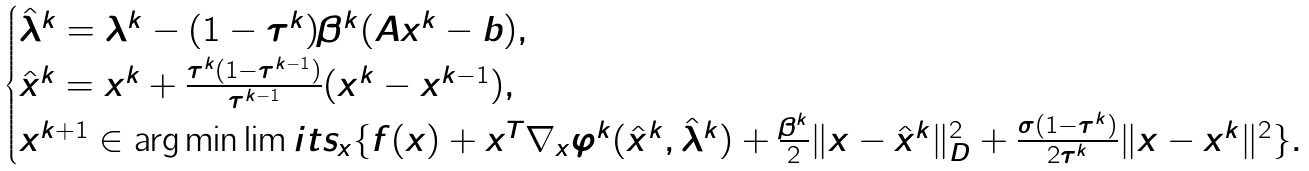<formula> <loc_0><loc_0><loc_500><loc_500>\begin{cases} \hat { \lambda } ^ { k } = \lambda ^ { k } - ( 1 - \tau ^ { k } ) \beta ^ { k } ( A { x } ^ { k } - b ) , \\ \hat { x } ^ { k } = x ^ { k } + \frac { \tau ^ { k } ( 1 - \tau ^ { k - 1 } ) } { \tau ^ { k - 1 } } ( x ^ { k } - x ^ { k - 1 } ) , \\ x ^ { k + 1 } \in \arg \min \lim i t s _ { x } \{ f ( x ) + x ^ { T } \nabla _ { x } \varphi ^ { k } ( \hat { x } ^ { k } , \hat { \lambda } ^ { k } ) + \frac { \beta ^ { k } } { 2 } \| x - \hat { x } ^ { k } \| _ { D } ^ { 2 } + \frac { \sigma ( 1 - \tau ^ { k } ) } { 2 \tau ^ { k } } \| x - x ^ { k } \| ^ { 2 } \} . \end{cases}</formula> 